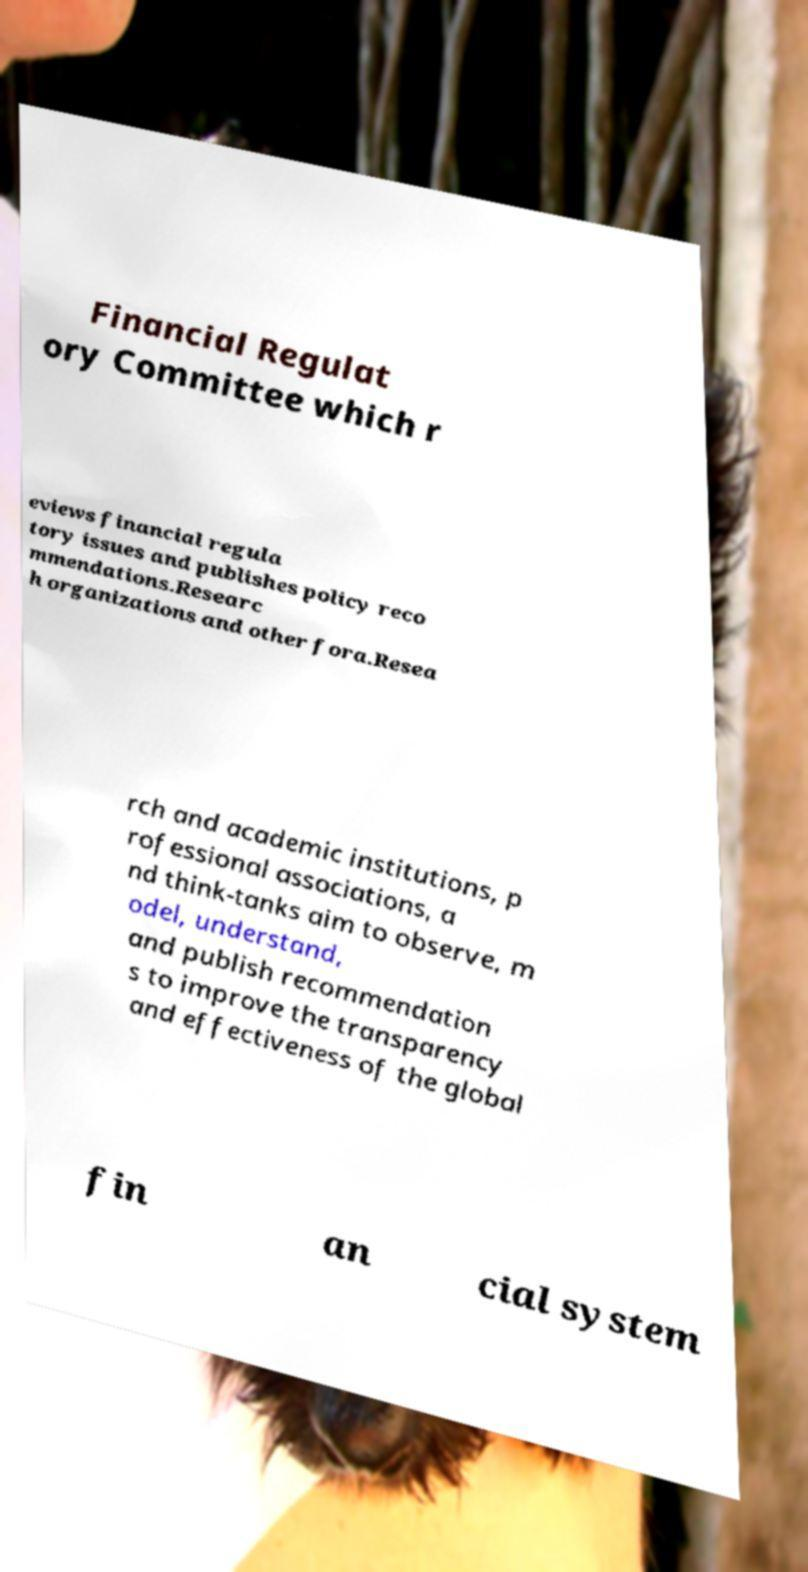Please read and relay the text visible in this image. What does it say? Financial Regulat ory Committee which r eviews financial regula tory issues and publishes policy reco mmendations.Researc h organizations and other fora.Resea rch and academic institutions, p rofessional associations, a nd think-tanks aim to observe, m odel, understand, and publish recommendation s to improve the transparency and effectiveness of the global fin an cial system 